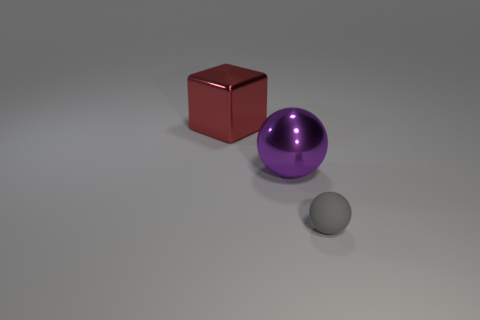Is there any other thing that is made of the same material as the tiny gray ball?
Offer a terse response. No. Do the small thing and the big object in front of the large red metal cube have the same material?
Make the answer very short. No. There is a big metallic object that is left of the big purple metal thing; what is its shape?
Your answer should be compact. Cube. Is there any other thing that is the same color as the tiny matte object?
Make the answer very short. No. Are there fewer spheres behind the red metal block than tiny yellow shiny blocks?
Your answer should be compact. No. What number of metallic balls are the same size as the red metallic thing?
Offer a very short reply. 1. What is the shape of the big object that is in front of the shiny thing that is left of the sphere that is behind the tiny gray rubber sphere?
Give a very brief answer. Sphere. What color is the ball that is in front of the metallic sphere?
Make the answer very short. Gray. What number of objects are either large objects that are in front of the red block or large things on the right side of the big red thing?
Ensure brevity in your answer.  1. What number of other metallic objects are the same shape as the purple object?
Your answer should be compact. 0. 